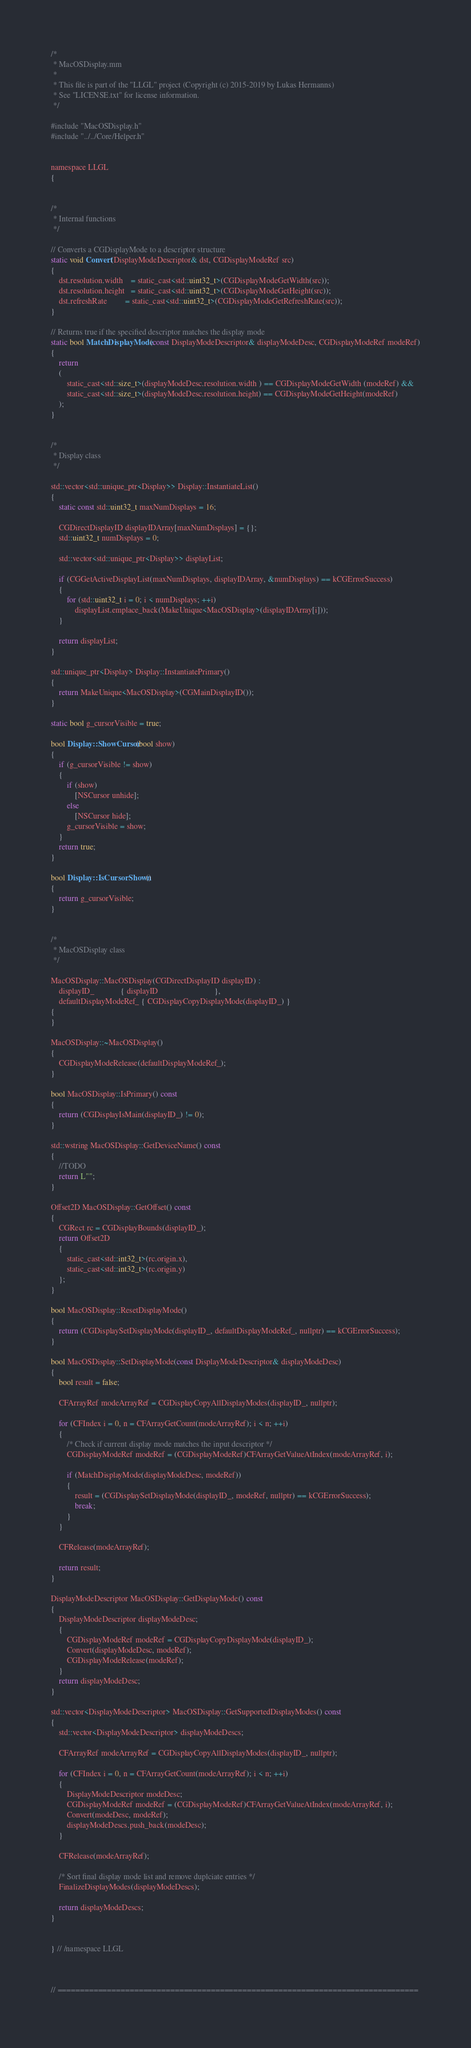Convert code to text. <code><loc_0><loc_0><loc_500><loc_500><_ObjectiveC_>/*
 * MacOSDisplay.mm
 * 
 * This file is part of the "LLGL" project (Copyright (c) 2015-2019 by Lukas Hermanns)
 * See "LICENSE.txt" for license information.
 */

#include "MacOSDisplay.h"
#include "../../Core/Helper.h"


namespace LLGL
{


/*
 * Internal functions
 */

// Converts a CGDisplayMode to a descriptor structure
static void Convert(DisplayModeDescriptor& dst, CGDisplayModeRef src)
{
    dst.resolution.width    = static_cast<std::uint32_t>(CGDisplayModeGetWidth(src));
    dst.resolution.height   = static_cast<std::uint32_t>(CGDisplayModeGetHeight(src));
    dst.refreshRate         = static_cast<std::uint32_t>(CGDisplayModeGetRefreshRate(src));
}

// Returns true if the specified descriptor matches the display mode
static bool MatchDisplayMode(const DisplayModeDescriptor& displayModeDesc, CGDisplayModeRef modeRef)
{
    return
    (
        static_cast<std::size_t>(displayModeDesc.resolution.width ) == CGDisplayModeGetWidth (modeRef) &&
        static_cast<std::size_t>(displayModeDesc.resolution.height) == CGDisplayModeGetHeight(modeRef)
    );
}


/*
 * Display class
 */

std::vector<std::unique_ptr<Display>> Display::InstantiateList()
{
    static const std::uint32_t maxNumDisplays = 16;

    CGDirectDisplayID displayIDArray[maxNumDisplays] = {};
    std::uint32_t numDisplays = 0;

    std::vector<std::unique_ptr<Display>> displayList;

    if (CGGetActiveDisplayList(maxNumDisplays, displayIDArray, &numDisplays) == kCGErrorSuccess)
    {
        for (std::uint32_t i = 0; i < numDisplays; ++i)
            displayList.emplace_back(MakeUnique<MacOSDisplay>(displayIDArray[i]));
    }

    return displayList;
}

std::unique_ptr<Display> Display::InstantiatePrimary()
{
    return MakeUnique<MacOSDisplay>(CGMainDisplayID());
}

static bool g_cursorVisible = true;

bool Display::ShowCursor(bool show)
{
    if (g_cursorVisible != show)
    {
        if (show)
            [NSCursor unhide];
        else
            [NSCursor hide];
        g_cursorVisible = show;
    }
    return true;
}

bool Display::IsCursorShown()
{
    return g_cursorVisible;
}


/*
 * MacOSDisplay class
 */

MacOSDisplay::MacOSDisplay(CGDirectDisplayID displayID) :
    displayID_             { displayID                            },
    defaultDisplayModeRef_ { CGDisplayCopyDisplayMode(displayID_) }
{
}

MacOSDisplay::~MacOSDisplay()
{
    CGDisplayModeRelease(defaultDisplayModeRef_);
}

bool MacOSDisplay::IsPrimary() const
{
    return (CGDisplayIsMain(displayID_) != 0);
}

std::wstring MacOSDisplay::GetDeviceName() const
{
    //TODO
    return L"";
}

Offset2D MacOSDisplay::GetOffset() const
{
    CGRect rc = CGDisplayBounds(displayID_);
    return Offset2D
    {
        static_cast<std::int32_t>(rc.origin.x),
        static_cast<std::int32_t>(rc.origin.y)
    };
}

bool MacOSDisplay::ResetDisplayMode()
{
    return (CGDisplaySetDisplayMode(displayID_, defaultDisplayModeRef_, nullptr) == kCGErrorSuccess);
}

bool MacOSDisplay::SetDisplayMode(const DisplayModeDescriptor& displayModeDesc)
{
    bool result = false;

    CFArrayRef modeArrayRef = CGDisplayCopyAllDisplayModes(displayID_, nullptr);

    for (CFIndex i = 0, n = CFArrayGetCount(modeArrayRef); i < n; ++i)
    {
        /* Check if current display mode matches the input descriptor */
        CGDisplayModeRef modeRef = (CGDisplayModeRef)CFArrayGetValueAtIndex(modeArrayRef, i);

        if (MatchDisplayMode(displayModeDesc, modeRef))
        {
            result = (CGDisplaySetDisplayMode(displayID_, modeRef, nullptr) == kCGErrorSuccess);
            break;
        }
    }

    CFRelease(modeArrayRef);

    return result;
}

DisplayModeDescriptor MacOSDisplay::GetDisplayMode() const
{
    DisplayModeDescriptor displayModeDesc;
    {
        CGDisplayModeRef modeRef = CGDisplayCopyDisplayMode(displayID_);
        Convert(displayModeDesc, modeRef);
        CGDisplayModeRelease(modeRef);
    }
    return displayModeDesc;
}

std::vector<DisplayModeDescriptor> MacOSDisplay::GetSupportedDisplayModes() const
{
    std::vector<DisplayModeDescriptor> displayModeDescs;

    CFArrayRef modeArrayRef = CGDisplayCopyAllDisplayModes(displayID_, nullptr);

    for (CFIndex i = 0, n = CFArrayGetCount(modeArrayRef); i < n; ++i)
    {
        DisplayModeDescriptor modeDesc;
        CGDisplayModeRef modeRef = (CGDisplayModeRef)CFArrayGetValueAtIndex(modeArrayRef, i);
        Convert(modeDesc, modeRef);
        displayModeDescs.push_back(modeDesc);
    }

    CFRelease(modeArrayRef);

    /* Sort final display mode list and remove duplciate entries */
    FinalizeDisplayModes(displayModeDescs);

    return displayModeDescs;
}


} // /namespace LLGL



// ================================================================================
</code> 